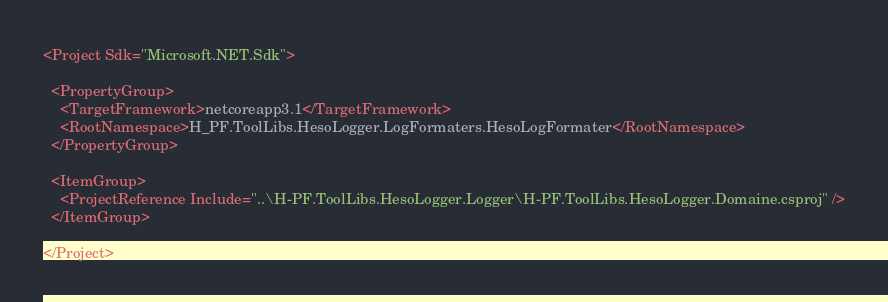<code> <loc_0><loc_0><loc_500><loc_500><_XML_><Project Sdk="Microsoft.NET.Sdk">

  <PropertyGroup>
    <TargetFramework>netcoreapp3.1</TargetFramework>
    <RootNamespace>H_PF.ToolLibs.HesoLogger.LogFormaters.HesoLogFormater</RootNamespace>
  </PropertyGroup>

  <ItemGroup>
    <ProjectReference Include="..\H-PF.ToolLibs.HesoLogger.Logger\H-PF.ToolLibs.HesoLogger.Domaine.csproj" />
  </ItemGroup>

</Project>
</code> 